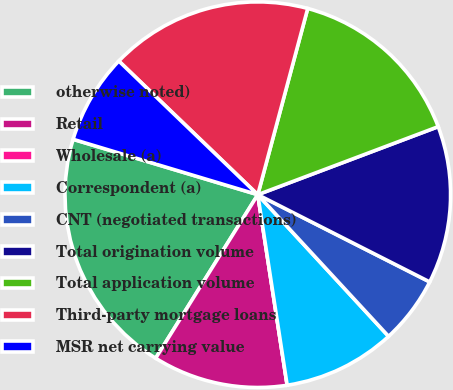<chart> <loc_0><loc_0><loc_500><loc_500><pie_chart><fcel>otherwise noted)<fcel>Retail<fcel>Wholesale (a)<fcel>Correspondent (a)<fcel>CNT (negotiated transactions)<fcel>Total origination volume<fcel>Total application volume<fcel>Third-party mortgage loans<fcel>MSR net carrying value<nl><fcel>20.75%<fcel>11.32%<fcel>0.0%<fcel>9.43%<fcel>5.66%<fcel>13.21%<fcel>15.09%<fcel>16.98%<fcel>7.55%<nl></chart> 